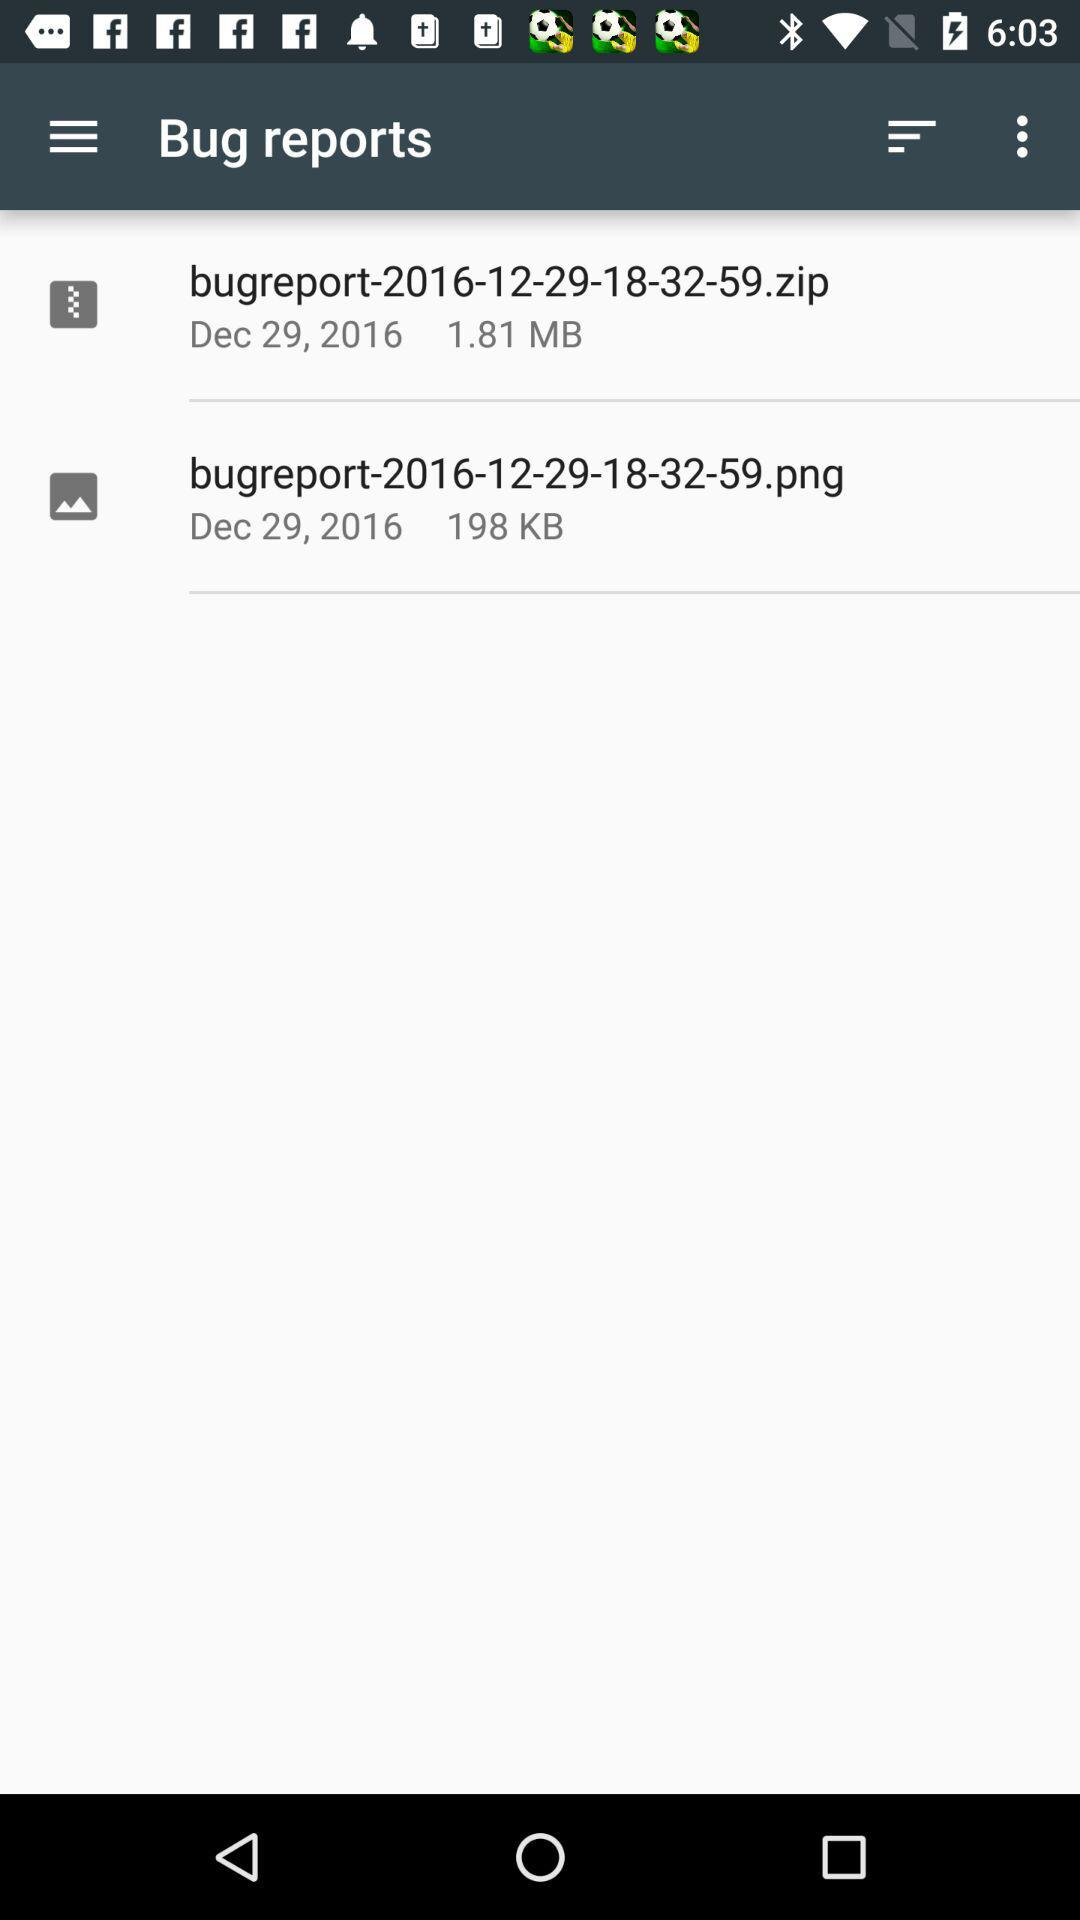How many items have been uploaded?
Answer the question using a single word or phrase. 2 